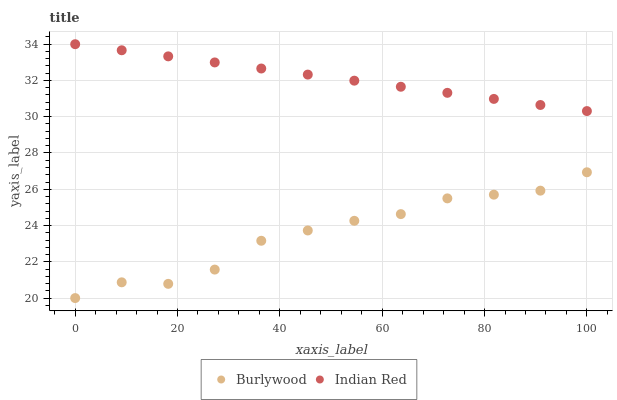Does Burlywood have the minimum area under the curve?
Answer yes or no. Yes. Does Indian Red have the maximum area under the curve?
Answer yes or no. Yes. Does Indian Red have the minimum area under the curve?
Answer yes or no. No. Is Indian Red the smoothest?
Answer yes or no. Yes. Is Burlywood the roughest?
Answer yes or no. Yes. Is Indian Red the roughest?
Answer yes or no. No. Does Burlywood have the lowest value?
Answer yes or no. Yes. Does Indian Red have the lowest value?
Answer yes or no. No. Does Indian Red have the highest value?
Answer yes or no. Yes. Is Burlywood less than Indian Red?
Answer yes or no. Yes. Is Indian Red greater than Burlywood?
Answer yes or no. Yes. Does Burlywood intersect Indian Red?
Answer yes or no. No. 